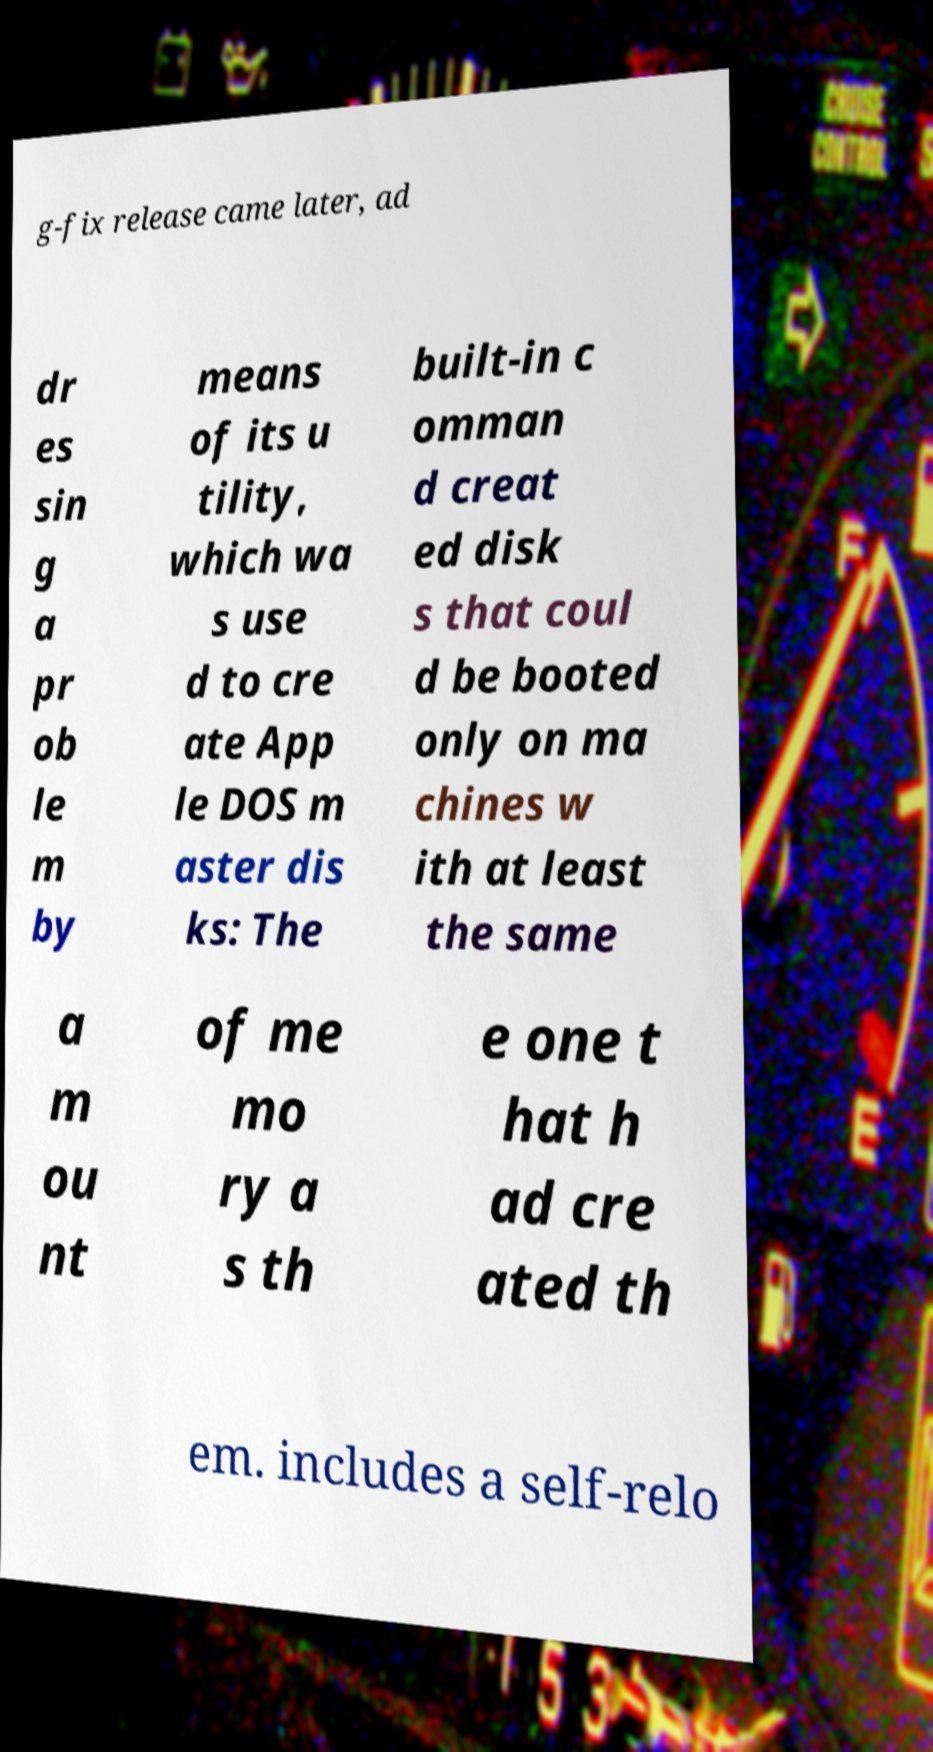Please identify and transcribe the text found in this image. g-fix release came later, ad dr es sin g a pr ob le m by means of its u tility, which wa s use d to cre ate App le DOS m aster dis ks: The built-in c omman d creat ed disk s that coul d be booted only on ma chines w ith at least the same a m ou nt of me mo ry a s th e one t hat h ad cre ated th em. includes a self-relo 